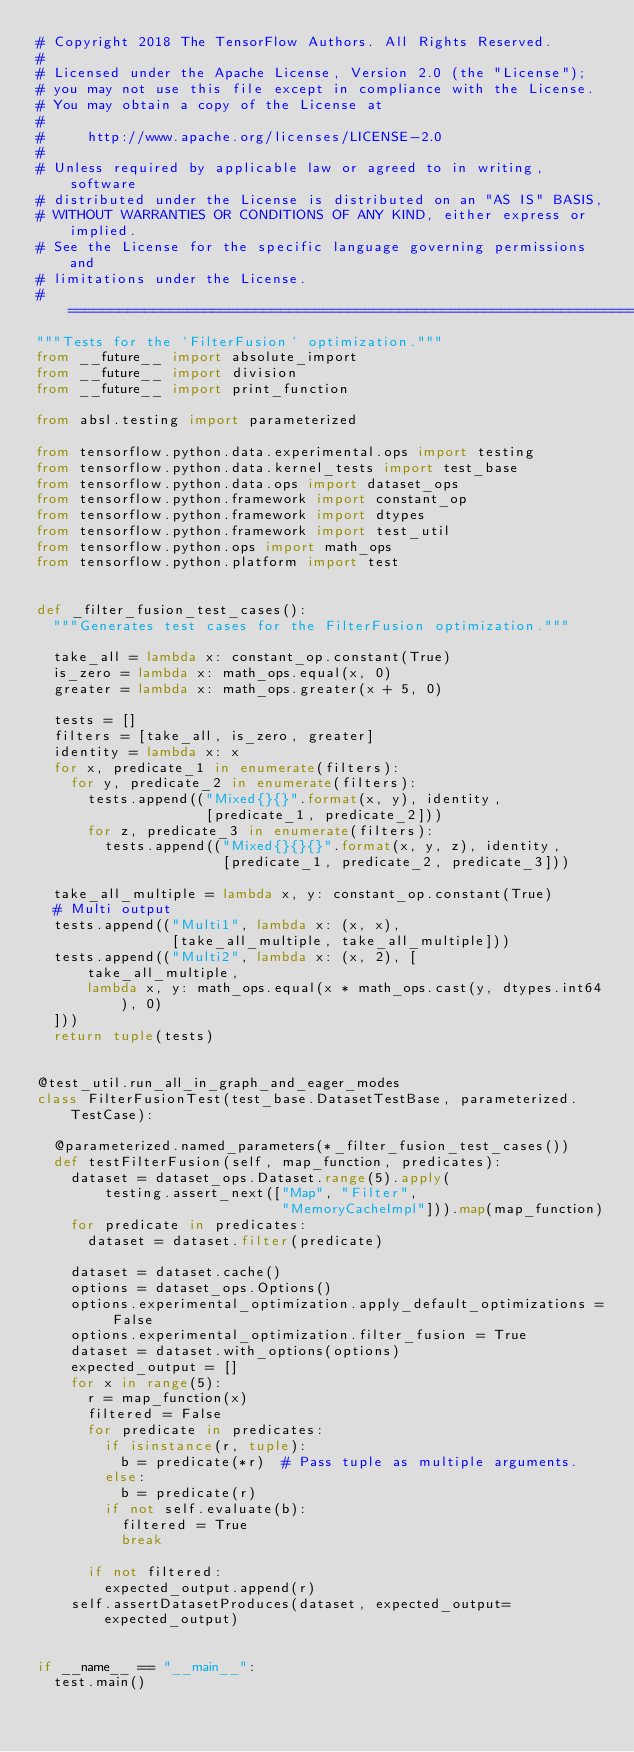Convert code to text. <code><loc_0><loc_0><loc_500><loc_500><_Python_># Copyright 2018 The TensorFlow Authors. All Rights Reserved.
#
# Licensed under the Apache License, Version 2.0 (the "License");
# you may not use this file except in compliance with the License.
# You may obtain a copy of the License at
#
#     http://www.apache.org/licenses/LICENSE-2.0
#
# Unless required by applicable law or agreed to in writing, software
# distributed under the License is distributed on an "AS IS" BASIS,
# WITHOUT WARRANTIES OR CONDITIONS OF ANY KIND, either express or implied.
# See the License for the specific language governing permissions and
# limitations under the License.
# ==============================================================================
"""Tests for the `FilterFusion` optimization."""
from __future__ import absolute_import
from __future__ import division
from __future__ import print_function

from absl.testing import parameterized

from tensorflow.python.data.experimental.ops import testing
from tensorflow.python.data.kernel_tests import test_base
from tensorflow.python.data.ops import dataset_ops
from tensorflow.python.framework import constant_op
from tensorflow.python.framework import dtypes
from tensorflow.python.framework import test_util
from tensorflow.python.ops import math_ops
from tensorflow.python.platform import test


def _filter_fusion_test_cases():
  """Generates test cases for the FilterFusion optimization."""

  take_all = lambda x: constant_op.constant(True)
  is_zero = lambda x: math_ops.equal(x, 0)
  greater = lambda x: math_ops.greater(x + 5, 0)

  tests = []
  filters = [take_all, is_zero, greater]
  identity = lambda x: x
  for x, predicate_1 in enumerate(filters):
    for y, predicate_2 in enumerate(filters):
      tests.append(("Mixed{}{}".format(x, y), identity,
                    [predicate_1, predicate_2]))
      for z, predicate_3 in enumerate(filters):
        tests.append(("Mixed{}{}{}".format(x, y, z), identity,
                      [predicate_1, predicate_2, predicate_3]))

  take_all_multiple = lambda x, y: constant_op.constant(True)
  # Multi output
  tests.append(("Multi1", lambda x: (x, x),
                [take_all_multiple, take_all_multiple]))
  tests.append(("Multi2", lambda x: (x, 2), [
      take_all_multiple,
      lambda x, y: math_ops.equal(x * math_ops.cast(y, dtypes.int64), 0)
  ]))
  return tuple(tests)


@test_util.run_all_in_graph_and_eager_modes
class FilterFusionTest(test_base.DatasetTestBase, parameterized.TestCase):

  @parameterized.named_parameters(*_filter_fusion_test_cases())
  def testFilterFusion(self, map_function, predicates):
    dataset = dataset_ops.Dataset.range(5).apply(
        testing.assert_next(["Map", "Filter",
                             "MemoryCacheImpl"])).map(map_function)
    for predicate in predicates:
      dataset = dataset.filter(predicate)

    dataset = dataset.cache()
    options = dataset_ops.Options()
    options.experimental_optimization.apply_default_optimizations = False
    options.experimental_optimization.filter_fusion = True
    dataset = dataset.with_options(options)
    expected_output = []
    for x in range(5):
      r = map_function(x)
      filtered = False
      for predicate in predicates:
        if isinstance(r, tuple):
          b = predicate(*r)  # Pass tuple as multiple arguments.
        else:
          b = predicate(r)
        if not self.evaluate(b):
          filtered = True
          break

      if not filtered:
        expected_output.append(r)
    self.assertDatasetProduces(dataset, expected_output=expected_output)


if __name__ == "__main__":
  test.main()
</code> 